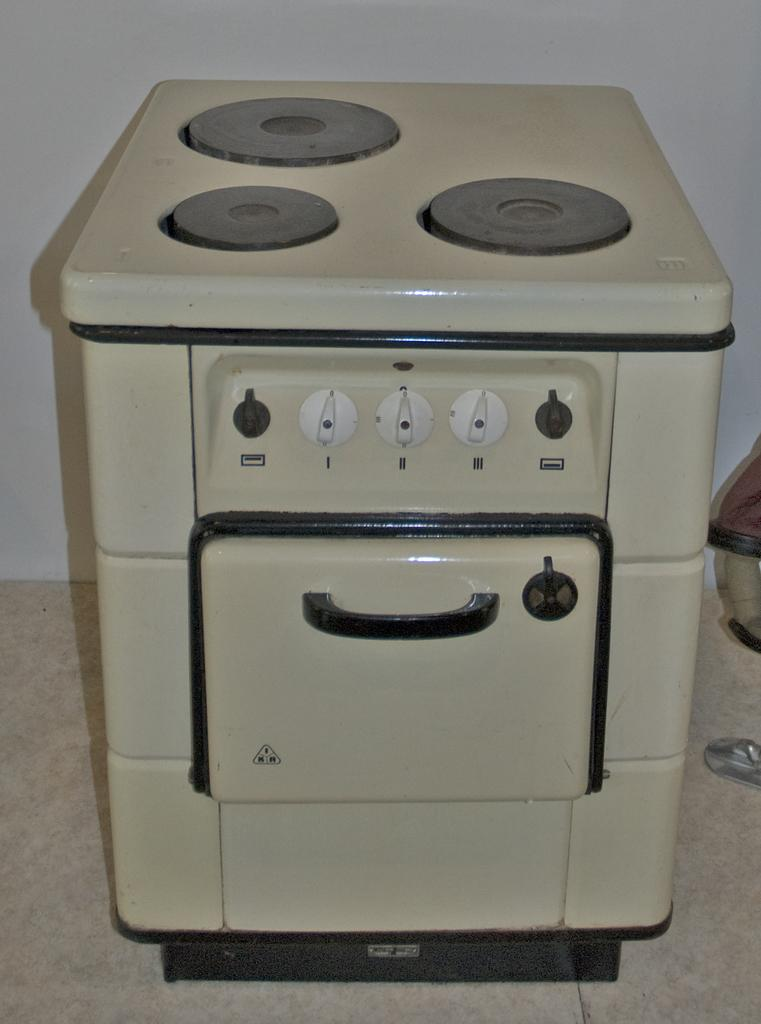What type of appliance is present in the image? There is a kitchen stove in the image. What color is the kitchen stove? The kitchen stove is white in color. Where is the kitchen stove located in the image? The kitchen stove is placed on the floor. What can be seen in the background of the image? There is a white color wall in the background of the image. What type of brush is used by the army in the image? There is no army or brush present in the image; it only features a white kitchen stove placed on the floor with a white wall in the background. 